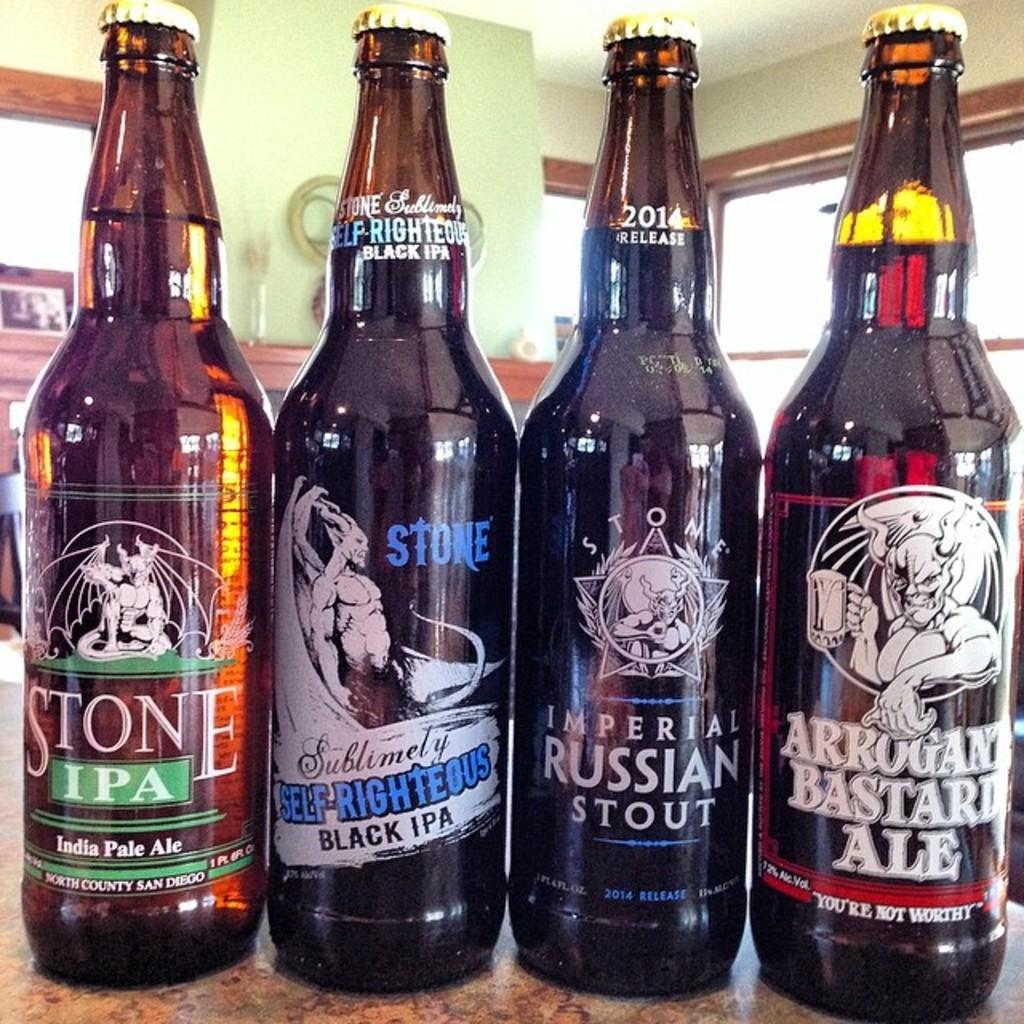<image>
Summarize the visual content of the image. 4 glasses of beer such as Stone IPA 